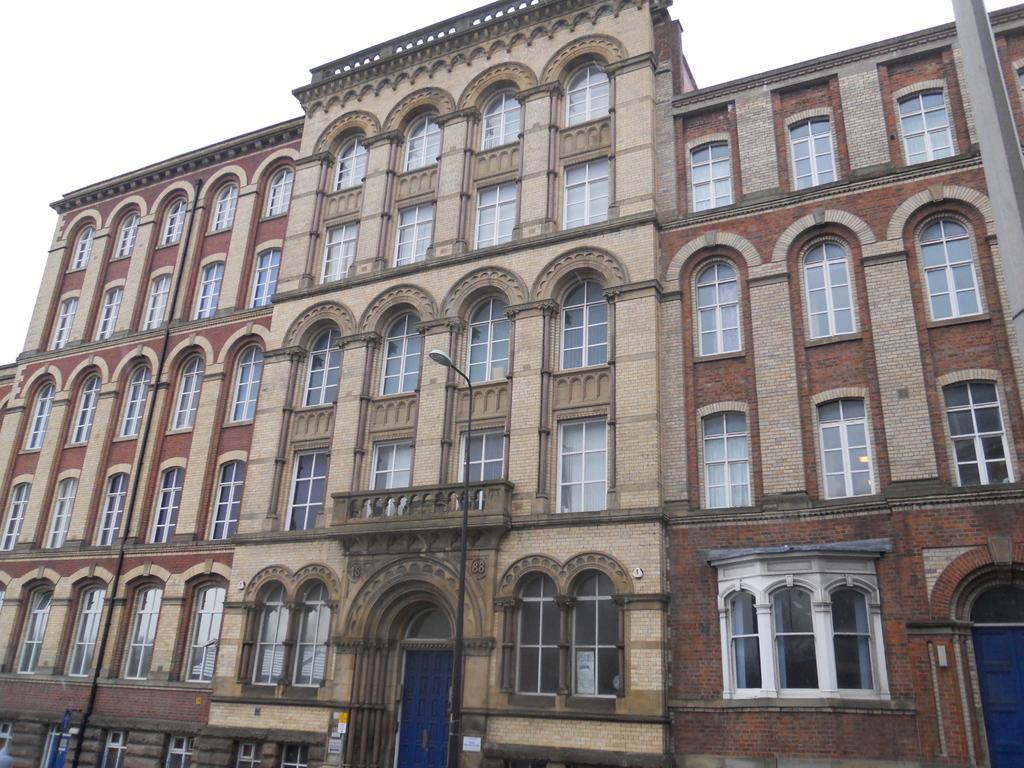How would you summarize this image in a sentence or two? In this image, we can see a few buildings with windows and doors. We can also see a pole. We can see the sky. 